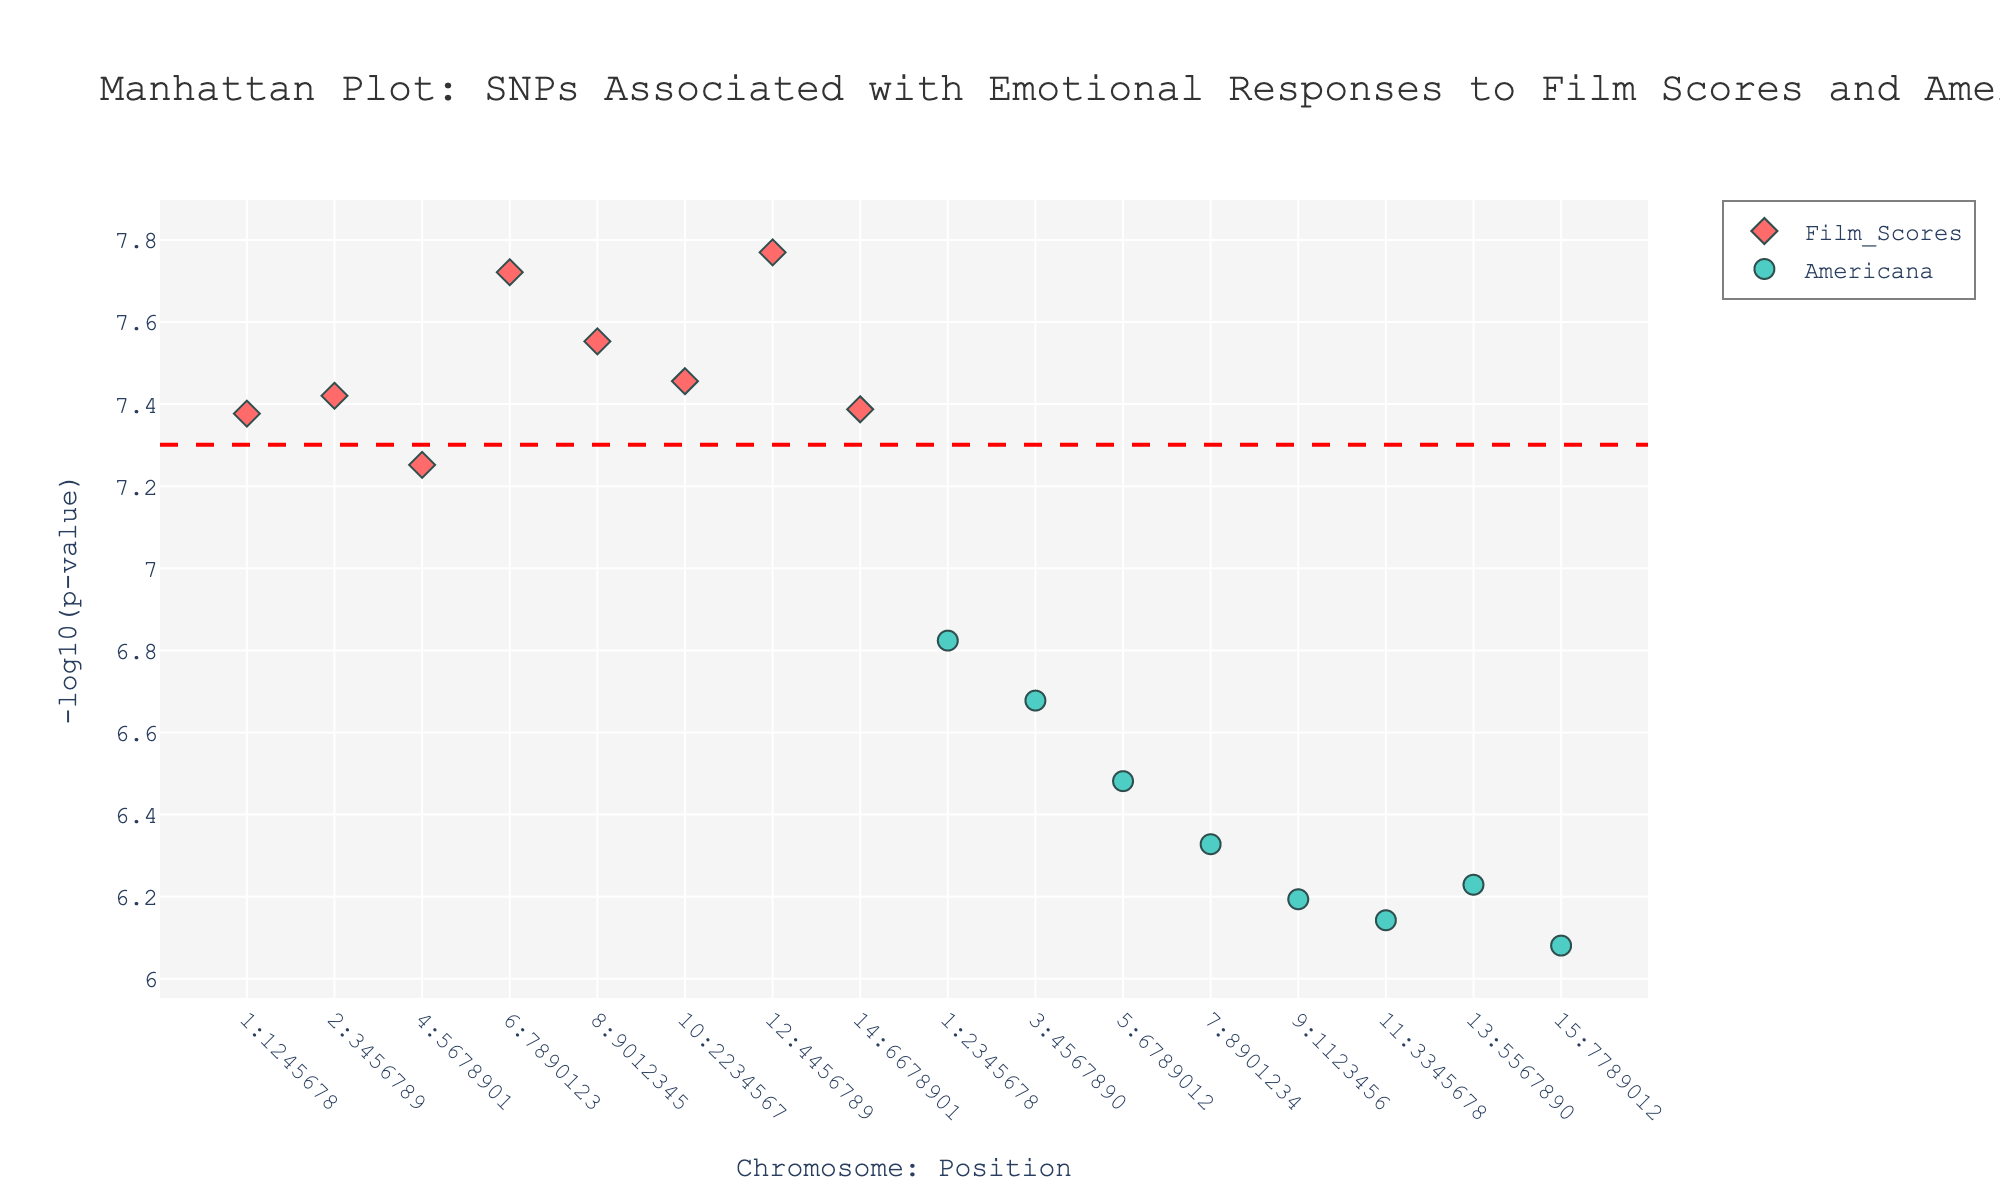what is the title of the figure? The title is usually prominently displayed at the top of the figure, in a larger and often bold font. Here, it states "Manhattan Plot: SNPs Associated with Emotional Responses to Film Scores and Americana".
Answer: Manhattan Plot: SNPs Associated with Emotional Responses to Film Scores and Americana What color markers are used for the Americana genre? The markers for Americana can be identified by looking at the legend or by observing the marker color on the plot. The legend shows that Americana markers are colored in turquoise.
Answer: Turquoise Which genre has more significant SNPs based on the plot? Determine which genre has more markers above the significance threshold line (red dashed line). By counting the markers, it appears that Film Scores has more significant SNPs above the line.
Answer: Film Scores How many SNPs are associated with emotional responses to Americana music? By observing the legend and counting the data points marked with the turquoise color (Americana), we can determine the number of Americana-associated SNPs.
Answer: 7 Which chromosome contains the SNP with the smallest p-value for film scores? The SNP with the smallest p-value will have the highest -log10(p-value) in the plot. For Film Scores, the highest red marker is on chromosome 12.
Answer: Chromosome 12 What is the gene associated with the most significant SNP for film scores? To find the most significant SNP for film scores, look for the highest red marker and then check the hover text or legend for the gene name. The highest marker (chromosome 12) is associated with the gene SLC6A4.
Answer: SLC6A4 Are there any genes that appear in both genres? Check the genes listed for each marker in both genres and see if any are repeated. The gene OXTR is associated with markers in both Film Scores and Americana.
Answer: OXTR Which genre shows a higher peak in -log10(p-value) around chromosome 1: Americana or Film Scores? Examine the plot for the highest peaks around chromosome 1 and compare the values between genres. Film Scores (red markers) have a higher peak compared to Americana (turquoise markers).
Answer: Film Scores What is the significance threshold in the plot, and how is it represented visually? Identify the significance threshold by the dashed line across the plot and its corresponding y-axis value. The threshold, represented by a red dashed line, marks the point where -log10(p-value) is around 7.3 (equivalent to a p-value of 5e-8).
Answer: -log10(p-value) of 7.3 